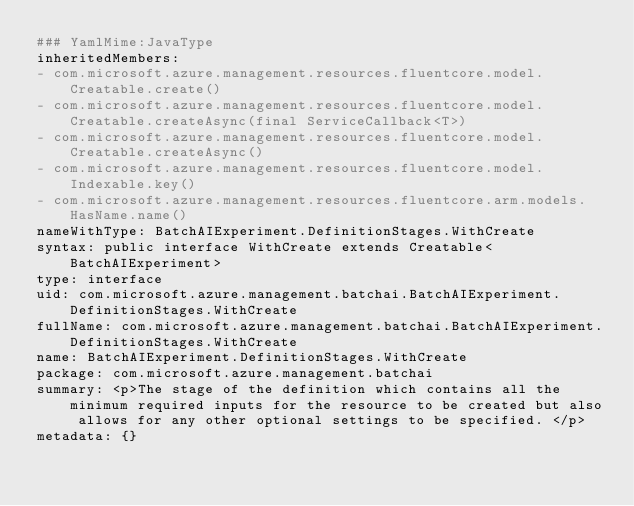Convert code to text. <code><loc_0><loc_0><loc_500><loc_500><_YAML_>### YamlMime:JavaType
inheritedMembers:
- com.microsoft.azure.management.resources.fluentcore.model.Creatable.create()
- com.microsoft.azure.management.resources.fluentcore.model.Creatable.createAsync(final ServiceCallback<T>)
- com.microsoft.azure.management.resources.fluentcore.model.Creatable.createAsync()
- com.microsoft.azure.management.resources.fluentcore.model.Indexable.key()
- com.microsoft.azure.management.resources.fluentcore.arm.models.HasName.name()
nameWithType: BatchAIExperiment.DefinitionStages.WithCreate
syntax: public interface WithCreate extends Creatable<BatchAIExperiment>
type: interface
uid: com.microsoft.azure.management.batchai.BatchAIExperiment.DefinitionStages.WithCreate
fullName: com.microsoft.azure.management.batchai.BatchAIExperiment.DefinitionStages.WithCreate
name: BatchAIExperiment.DefinitionStages.WithCreate
package: com.microsoft.azure.management.batchai
summary: <p>The stage of the definition which contains all the minimum required inputs for the resource to be created but also allows for any other optional settings to be specified. </p>
metadata: {}
</code> 